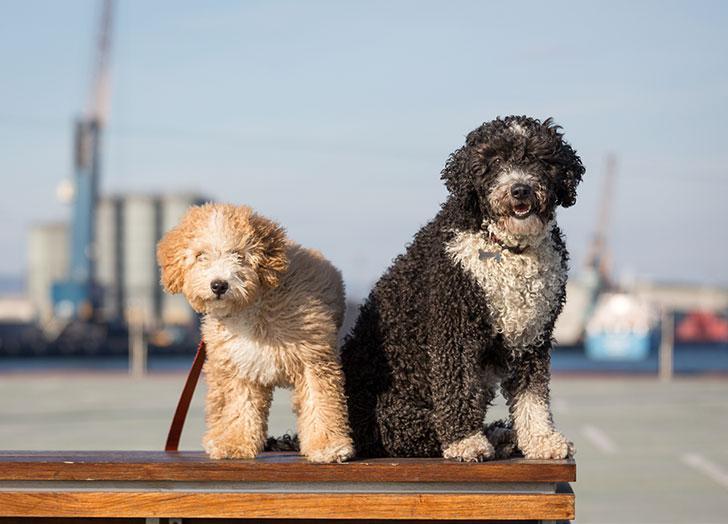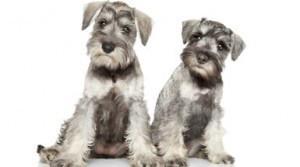The first image is the image on the left, the second image is the image on the right. Examine the images to the left and right. Is the description "The image on the right shows two dogs sitting next to each other outside." accurate? Answer yes or no. No. The first image is the image on the left, the second image is the image on the right. Examine the images to the left and right. Is the description "In at least one of the images, two dog from the same breed are sitting next to each other." accurate? Answer yes or no. Yes. 